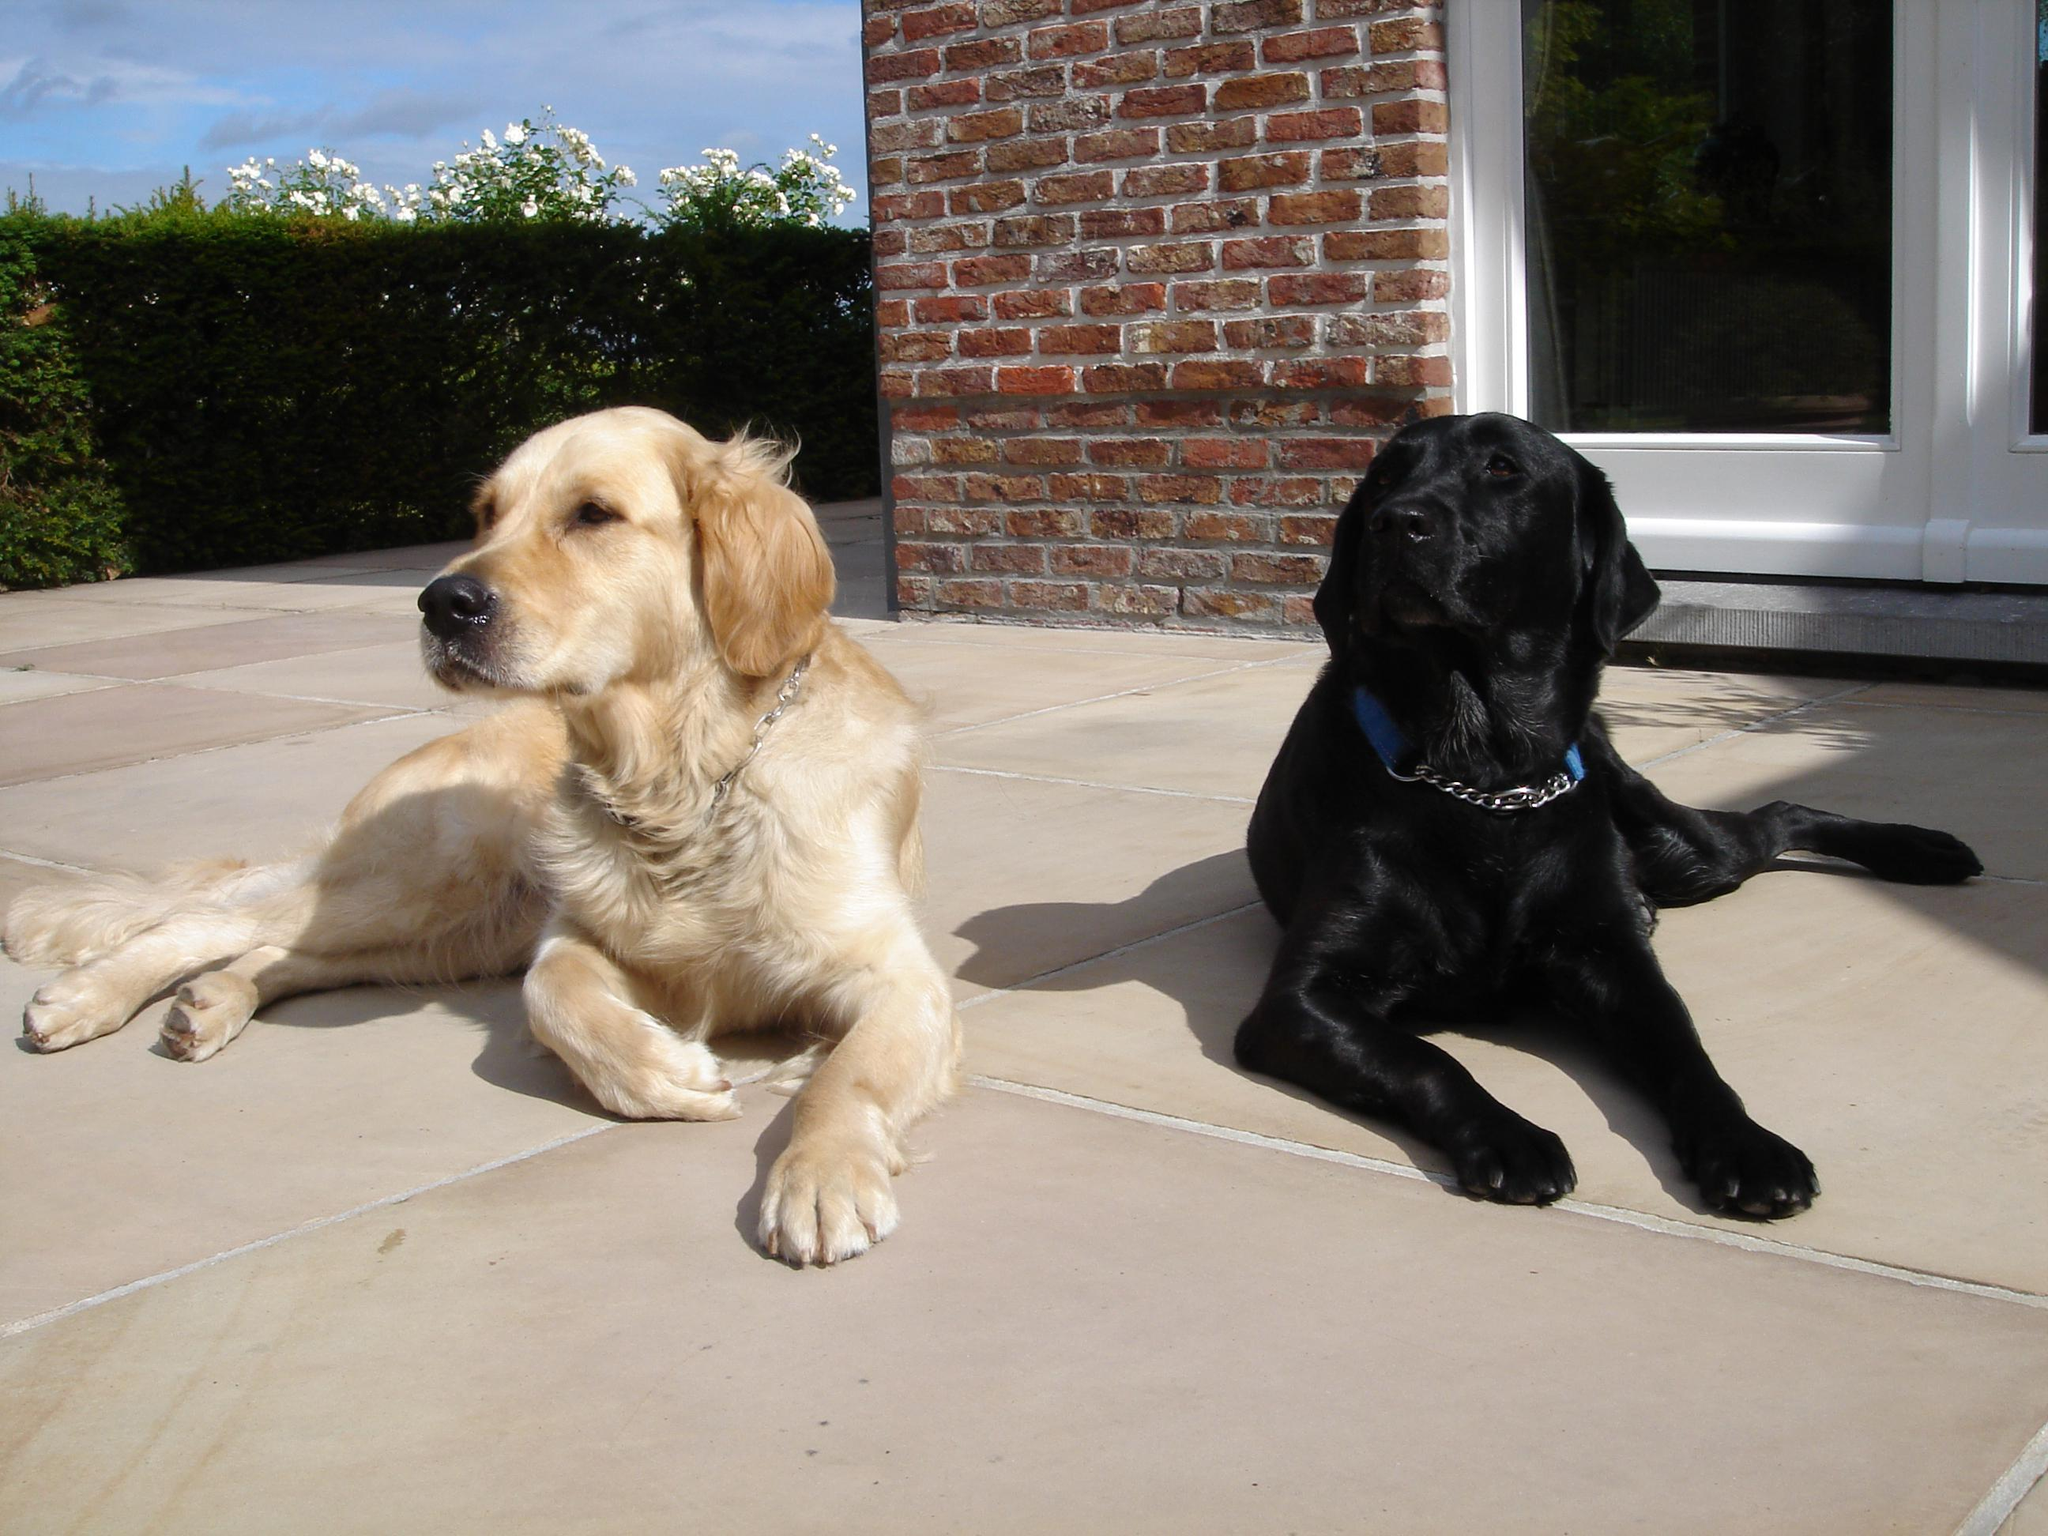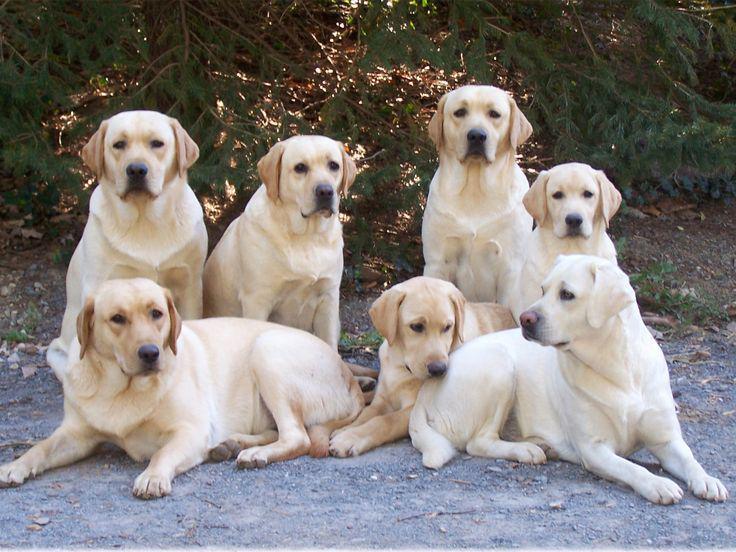The first image is the image on the left, the second image is the image on the right. For the images displayed, is the sentence "There are more dogs in the image on the left." factually correct? Answer yes or no. No. The first image is the image on the left, the second image is the image on the right. Given the left and right images, does the statement "One image shows exactly two adult dogs, and the other image shows a row of at least three puppies sitting upright." hold true? Answer yes or no. No. 